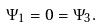<formula> <loc_0><loc_0><loc_500><loc_500>\Psi _ { 1 } = 0 = \Psi _ { 3 } .</formula> 